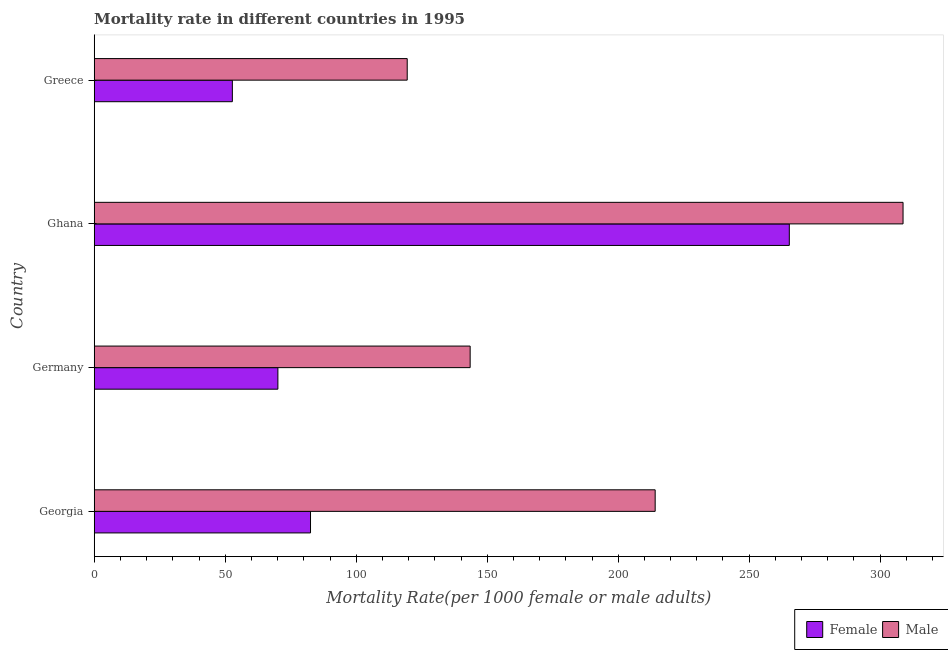How many groups of bars are there?
Make the answer very short. 4. Are the number of bars on each tick of the Y-axis equal?
Your response must be concise. Yes. How many bars are there on the 2nd tick from the top?
Your answer should be very brief. 2. How many bars are there on the 3rd tick from the bottom?
Make the answer very short. 2. What is the label of the 1st group of bars from the top?
Offer a very short reply. Greece. What is the male mortality rate in Greece?
Your answer should be very brief. 119.47. Across all countries, what is the maximum female mortality rate?
Offer a terse response. 265.31. Across all countries, what is the minimum female mortality rate?
Your answer should be very brief. 52.73. In which country was the female mortality rate minimum?
Your answer should be very brief. Greece. What is the total female mortality rate in the graph?
Offer a terse response. 470.72. What is the difference between the male mortality rate in Georgia and that in Germany?
Your response must be concise. 70.62. What is the difference between the male mortality rate in Ghana and the female mortality rate in Greece?
Provide a succinct answer. 255.99. What is the average female mortality rate per country?
Offer a terse response. 117.68. What is the difference between the female mortality rate and male mortality rate in Ghana?
Make the answer very short. -43.41. What is the ratio of the female mortality rate in Ghana to that in Greece?
Offer a terse response. 5.03. Is the difference between the male mortality rate in Georgia and Germany greater than the difference between the female mortality rate in Georgia and Germany?
Make the answer very short. Yes. What is the difference between the highest and the second highest female mortality rate?
Give a very brief answer. 182.75. What is the difference between the highest and the lowest female mortality rate?
Keep it short and to the point. 212.58. In how many countries, is the male mortality rate greater than the average male mortality rate taken over all countries?
Provide a succinct answer. 2. What does the 1st bar from the top in Greece represents?
Ensure brevity in your answer.  Male. What does the 2nd bar from the bottom in Germany represents?
Offer a terse response. Male. How many bars are there?
Offer a terse response. 8. Are all the bars in the graph horizontal?
Keep it short and to the point. Yes. What is the difference between two consecutive major ticks on the X-axis?
Give a very brief answer. 50. Does the graph contain any zero values?
Your answer should be very brief. No. Where does the legend appear in the graph?
Ensure brevity in your answer.  Bottom right. How many legend labels are there?
Your response must be concise. 2. What is the title of the graph?
Provide a succinct answer. Mortality rate in different countries in 1995. Does "Subsidies" appear as one of the legend labels in the graph?
Ensure brevity in your answer.  No. What is the label or title of the X-axis?
Offer a very short reply. Mortality Rate(per 1000 female or male adults). What is the label or title of the Y-axis?
Offer a very short reply. Country. What is the Mortality Rate(per 1000 female or male adults) of Female in Georgia?
Provide a succinct answer. 82.56. What is the Mortality Rate(per 1000 female or male adults) in Male in Georgia?
Give a very brief answer. 214.11. What is the Mortality Rate(per 1000 female or male adults) of Female in Germany?
Make the answer very short. 70.11. What is the Mortality Rate(per 1000 female or male adults) in Male in Germany?
Offer a terse response. 143.49. What is the Mortality Rate(per 1000 female or male adults) in Female in Ghana?
Your answer should be compact. 265.31. What is the Mortality Rate(per 1000 female or male adults) in Male in Ghana?
Keep it short and to the point. 308.73. What is the Mortality Rate(per 1000 female or male adults) in Female in Greece?
Provide a short and direct response. 52.73. What is the Mortality Rate(per 1000 female or male adults) in Male in Greece?
Make the answer very short. 119.47. Across all countries, what is the maximum Mortality Rate(per 1000 female or male adults) in Female?
Your response must be concise. 265.31. Across all countries, what is the maximum Mortality Rate(per 1000 female or male adults) of Male?
Your answer should be compact. 308.73. Across all countries, what is the minimum Mortality Rate(per 1000 female or male adults) in Female?
Give a very brief answer. 52.73. Across all countries, what is the minimum Mortality Rate(per 1000 female or male adults) in Male?
Your answer should be compact. 119.47. What is the total Mortality Rate(per 1000 female or male adults) in Female in the graph?
Provide a short and direct response. 470.72. What is the total Mortality Rate(per 1000 female or male adults) in Male in the graph?
Give a very brief answer. 785.8. What is the difference between the Mortality Rate(per 1000 female or male adults) in Female in Georgia and that in Germany?
Your response must be concise. 12.45. What is the difference between the Mortality Rate(per 1000 female or male adults) of Male in Georgia and that in Germany?
Make the answer very short. 70.62. What is the difference between the Mortality Rate(per 1000 female or male adults) in Female in Georgia and that in Ghana?
Your response must be concise. -182.75. What is the difference between the Mortality Rate(per 1000 female or male adults) in Male in Georgia and that in Ghana?
Provide a short and direct response. -94.61. What is the difference between the Mortality Rate(per 1000 female or male adults) of Female in Georgia and that in Greece?
Make the answer very short. 29.83. What is the difference between the Mortality Rate(per 1000 female or male adults) of Male in Georgia and that in Greece?
Offer a very short reply. 94.64. What is the difference between the Mortality Rate(per 1000 female or male adults) of Female in Germany and that in Ghana?
Your answer should be compact. -195.2. What is the difference between the Mortality Rate(per 1000 female or male adults) in Male in Germany and that in Ghana?
Your answer should be compact. -165.23. What is the difference between the Mortality Rate(per 1000 female or male adults) in Female in Germany and that in Greece?
Offer a very short reply. 17.38. What is the difference between the Mortality Rate(per 1000 female or male adults) in Male in Germany and that in Greece?
Offer a terse response. 24.02. What is the difference between the Mortality Rate(per 1000 female or male adults) in Female in Ghana and that in Greece?
Offer a terse response. 212.58. What is the difference between the Mortality Rate(per 1000 female or male adults) of Male in Ghana and that in Greece?
Your answer should be compact. 189.25. What is the difference between the Mortality Rate(per 1000 female or male adults) of Female in Georgia and the Mortality Rate(per 1000 female or male adults) of Male in Germany?
Offer a very short reply. -60.93. What is the difference between the Mortality Rate(per 1000 female or male adults) of Female in Georgia and the Mortality Rate(per 1000 female or male adults) of Male in Ghana?
Your answer should be compact. -226.16. What is the difference between the Mortality Rate(per 1000 female or male adults) of Female in Georgia and the Mortality Rate(per 1000 female or male adults) of Male in Greece?
Give a very brief answer. -36.91. What is the difference between the Mortality Rate(per 1000 female or male adults) in Female in Germany and the Mortality Rate(per 1000 female or male adults) in Male in Ghana?
Offer a terse response. -238.61. What is the difference between the Mortality Rate(per 1000 female or male adults) in Female in Germany and the Mortality Rate(per 1000 female or male adults) in Male in Greece?
Offer a very short reply. -49.36. What is the difference between the Mortality Rate(per 1000 female or male adults) in Female in Ghana and the Mortality Rate(per 1000 female or male adults) in Male in Greece?
Ensure brevity in your answer.  145.84. What is the average Mortality Rate(per 1000 female or male adults) in Female per country?
Provide a short and direct response. 117.68. What is the average Mortality Rate(per 1000 female or male adults) in Male per country?
Provide a succinct answer. 196.45. What is the difference between the Mortality Rate(per 1000 female or male adults) in Female and Mortality Rate(per 1000 female or male adults) in Male in Georgia?
Your response must be concise. -131.55. What is the difference between the Mortality Rate(per 1000 female or male adults) of Female and Mortality Rate(per 1000 female or male adults) of Male in Germany?
Offer a terse response. -73.38. What is the difference between the Mortality Rate(per 1000 female or male adults) of Female and Mortality Rate(per 1000 female or male adults) of Male in Ghana?
Your response must be concise. -43.41. What is the difference between the Mortality Rate(per 1000 female or male adults) of Female and Mortality Rate(per 1000 female or male adults) of Male in Greece?
Offer a very short reply. -66.74. What is the ratio of the Mortality Rate(per 1000 female or male adults) in Female in Georgia to that in Germany?
Keep it short and to the point. 1.18. What is the ratio of the Mortality Rate(per 1000 female or male adults) in Male in Georgia to that in Germany?
Provide a succinct answer. 1.49. What is the ratio of the Mortality Rate(per 1000 female or male adults) of Female in Georgia to that in Ghana?
Offer a very short reply. 0.31. What is the ratio of the Mortality Rate(per 1000 female or male adults) of Male in Georgia to that in Ghana?
Keep it short and to the point. 0.69. What is the ratio of the Mortality Rate(per 1000 female or male adults) in Female in Georgia to that in Greece?
Your answer should be very brief. 1.57. What is the ratio of the Mortality Rate(per 1000 female or male adults) in Male in Georgia to that in Greece?
Provide a succinct answer. 1.79. What is the ratio of the Mortality Rate(per 1000 female or male adults) of Female in Germany to that in Ghana?
Keep it short and to the point. 0.26. What is the ratio of the Mortality Rate(per 1000 female or male adults) in Male in Germany to that in Ghana?
Offer a terse response. 0.46. What is the ratio of the Mortality Rate(per 1000 female or male adults) in Female in Germany to that in Greece?
Provide a short and direct response. 1.33. What is the ratio of the Mortality Rate(per 1000 female or male adults) of Male in Germany to that in Greece?
Offer a terse response. 1.2. What is the ratio of the Mortality Rate(per 1000 female or male adults) of Female in Ghana to that in Greece?
Give a very brief answer. 5.03. What is the ratio of the Mortality Rate(per 1000 female or male adults) of Male in Ghana to that in Greece?
Make the answer very short. 2.58. What is the difference between the highest and the second highest Mortality Rate(per 1000 female or male adults) in Female?
Offer a terse response. 182.75. What is the difference between the highest and the second highest Mortality Rate(per 1000 female or male adults) of Male?
Provide a short and direct response. 94.61. What is the difference between the highest and the lowest Mortality Rate(per 1000 female or male adults) of Female?
Ensure brevity in your answer.  212.58. What is the difference between the highest and the lowest Mortality Rate(per 1000 female or male adults) in Male?
Ensure brevity in your answer.  189.25. 